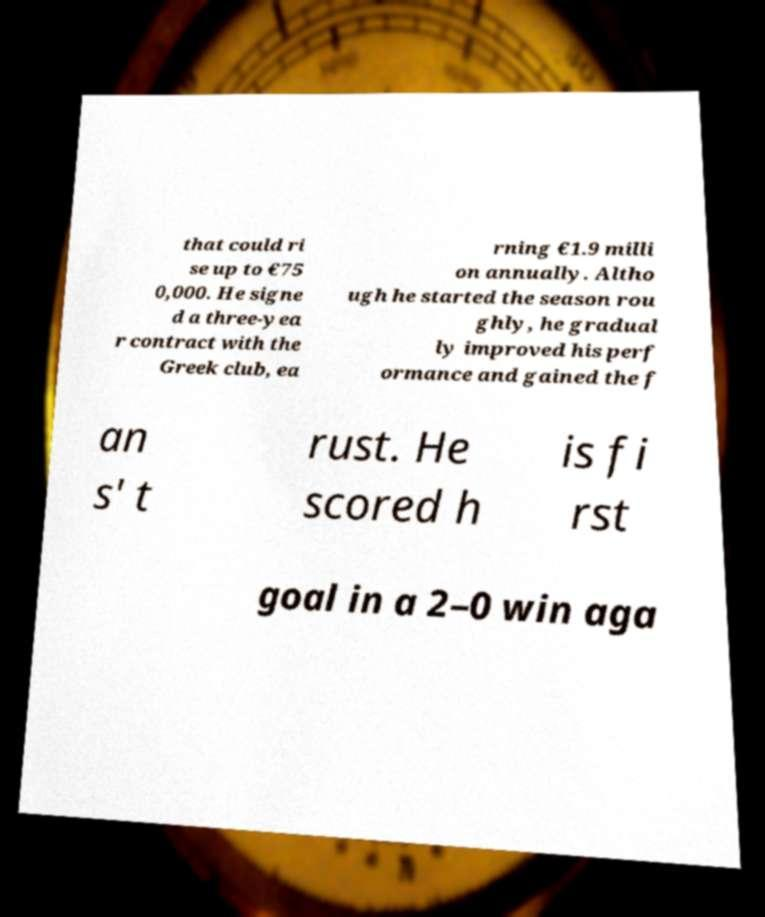There's text embedded in this image that I need extracted. Can you transcribe it verbatim? that could ri se up to €75 0,000. He signe d a three-yea r contract with the Greek club, ea rning €1.9 milli on annually. Altho ugh he started the season rou ghly, he gradual ly improved his perf ormance and gained the f an s' t rust. He scored h is fi rst goal in a 2–0 win aga 